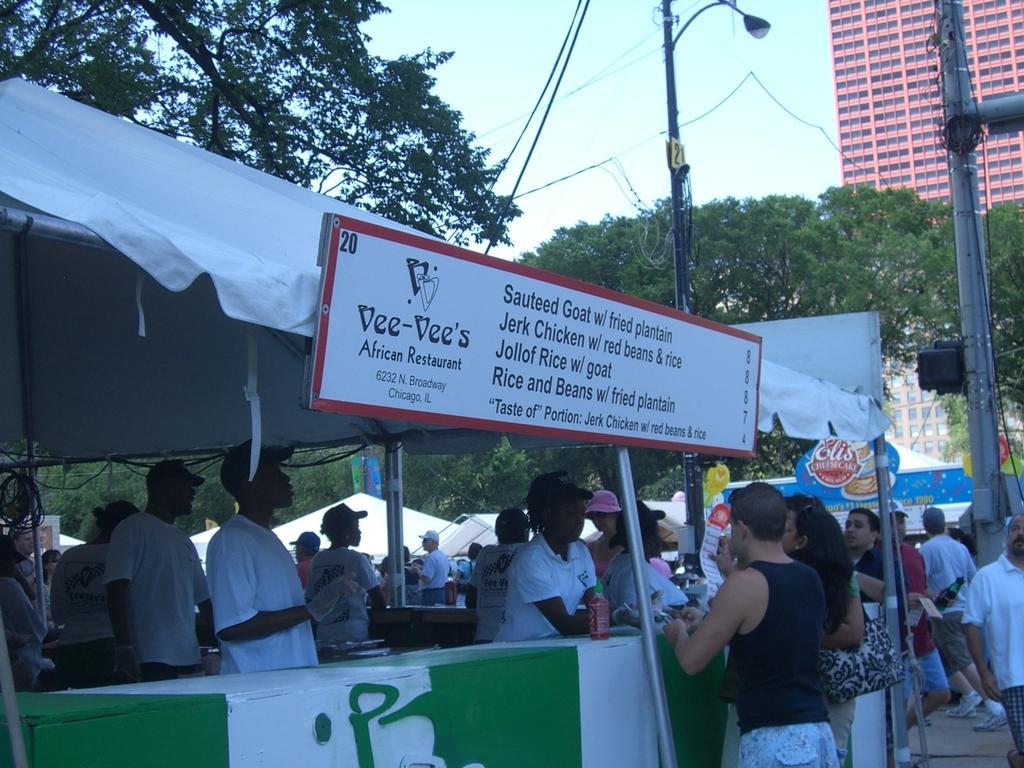Could you give a brief overview of what you see in this image? In this image I see number of people and I see a board over here on which there are words written and I see few stalls. In the background I see the trees, poles, wires, a building over here and I see the sky. 